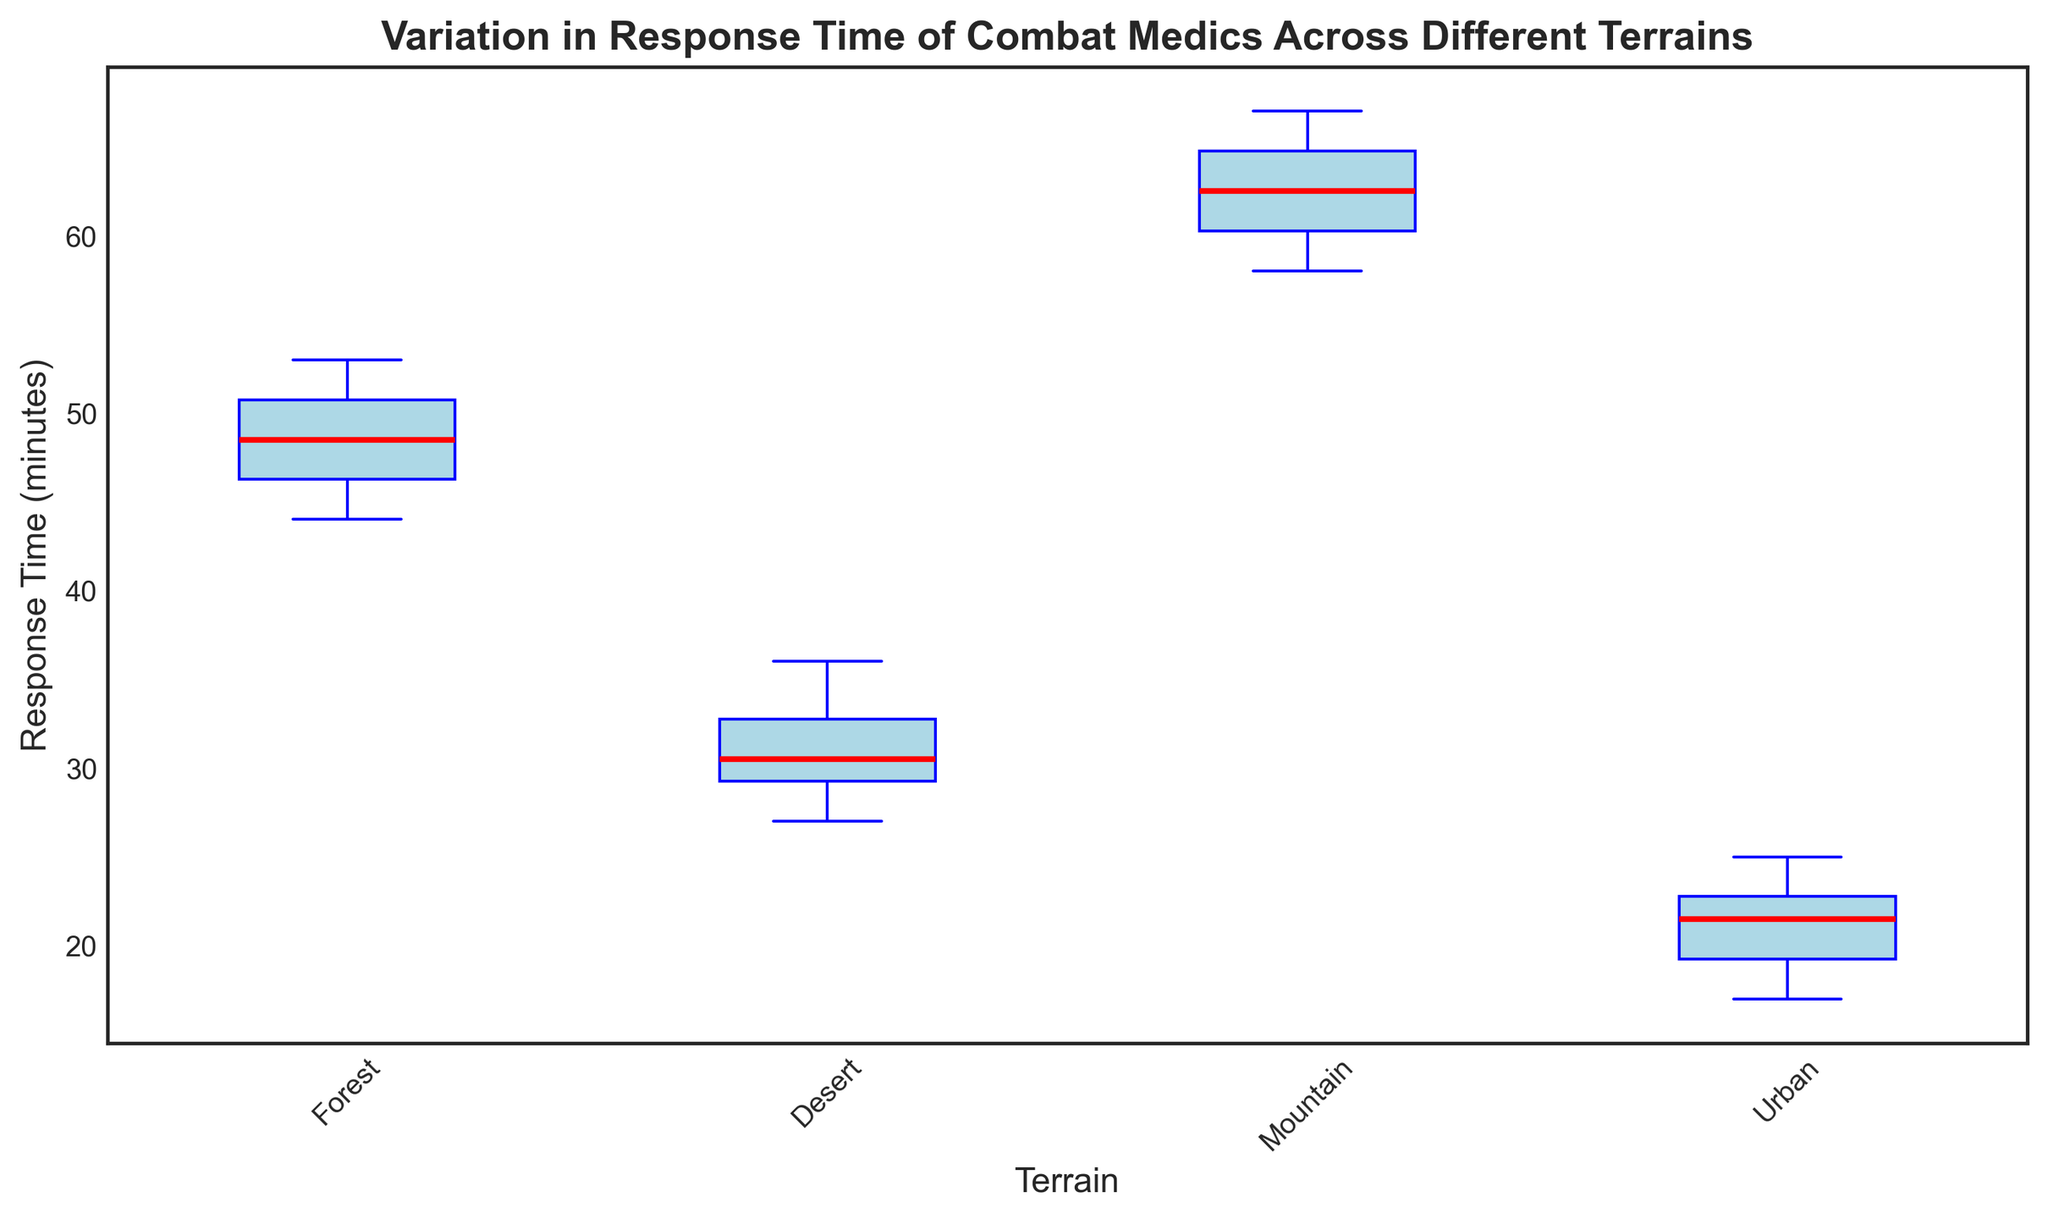What is the median response time for the Desert terrain? First, locate the median line within the boxplot for the Desert terrain to find the median value.
Answer: 30 Which terrain has the highest median response time? Compare the median lines of all the terrains and identify the highest one, which corresponds to the terrain with the highest median response time.
Answer: Mountain In which terrain do combat medics have the least variation in response times? Look for the terrain with the narrowest interquartile range (IQR), which is the distance between the lower and upper quartiles.
Answer: Urban How much longer is the median response time in the Forest compared to the Desert? Subtract the median response time of the Desert from that of the Forest: Forest median (approx. 48) - Desert median (30).
Answer: 18 minutes Which terrain shows the most outliers in combat medic response times? Observe the number of outlier points (red markers) in each boxplot to determine which terrain has the most.
Answer: None; all terrains have no outliers What are the approximate minimum and maximum response times for the Forest terrain? Identify the lower whisker (minimum) and upper whisker (maximum) of the Forest terrain boxplot.
Answer: 44, 53 Is the median response time in the Urban terrain less than 20 minutes? Observe the position of the median line in the Urban terrain boxplot: if it's below the 20-minute mark.
Answer: No Which terrain has the widest range between the minimum and maximum response times? Compare the distances between the whiskers for each terrain to see which has the widest range.
Answer: Mountain Are the medians of the Urban and Desert terrains closer to each other or to the medians of the Mountain and Forest terrains? Compare the median values between each pair: Urban and Desert vs. Mountain and Forest.
Answer: Closer to each other What are the quartiles (Q1 and Q3) for the Mountain terrain? Identify the positions of the lower quartile (Q1, bottom edge of the box) and upper quartile (Q3, top edge of the box) for the Mountain terrain.
Answer: Q1: 60, Q3: 65 